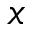Convert formula to latex. <formula><loc_0><loc_0><loc_500><loc_500>x</formula> 